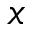Convert formula to latex. <formula><loc_0><loc_0><loc_500><loc_500>x</formula> 